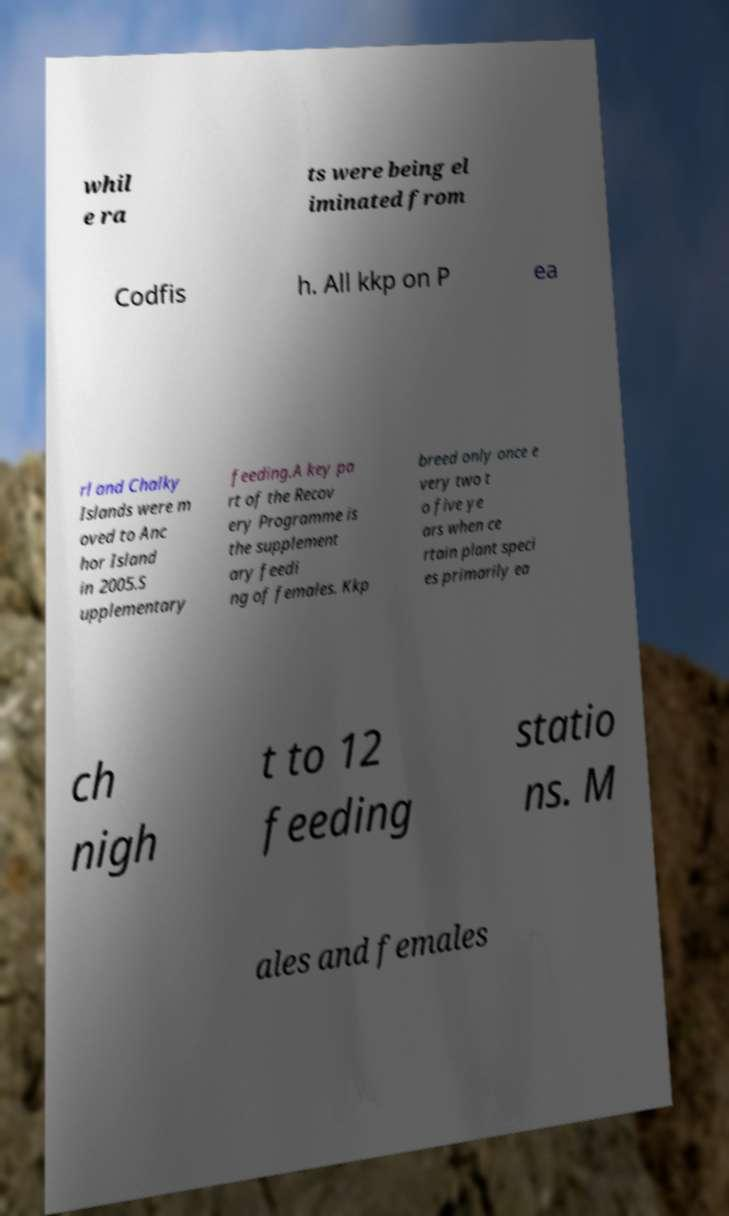I need the written content from this picture converted into text. Can you do that? whil e ra ts were being el iminated from Codfis h. All kkp on P ea rl and Chalky Islands were m oved to Anc hor Island in 2005.S upplementary feeding.A key pa rt of the Recov ery Programme is the supplement ary feedi ng of females. Kkp breed only once e very two t o five ye ars when ce rtain plant speci es primarily ea ch nigh t to 12 feeding statio ns. M ales and females 